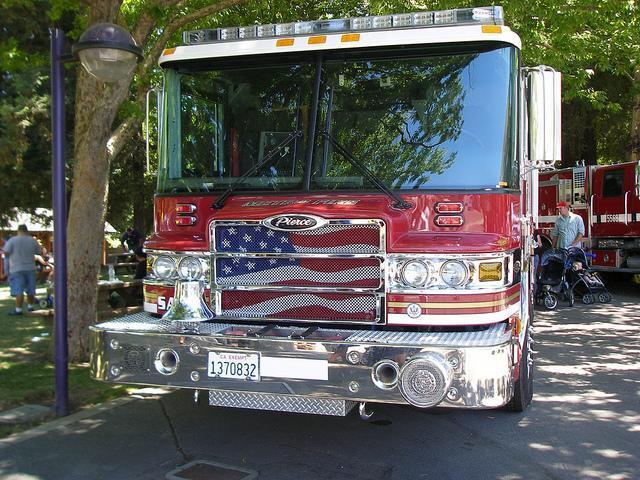How many trucks can you see?
Give a very brief answer. 2. How many books are on the floor?
Give a very brief answer. 0. 